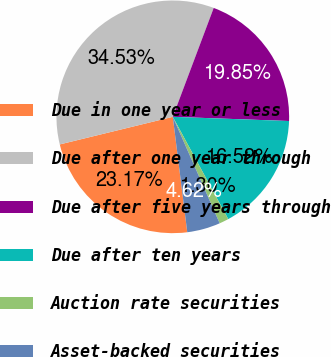Convert chart. <chart><loc_0><loc_0><loc_500><loc_500><pie_chart><fcel>Due in one year or less<fcel>Due after one year through<fcel>Due after five years through<fcel>Due after ten years<fcel>Auction rate securities<fcel>Asset-backed securities<nl><fcel>23.17%<fcel>34.53%<fcel>19.85%<fcel>16.52%<fcel>1.3%<fcel>4.62%<nl></chart> 